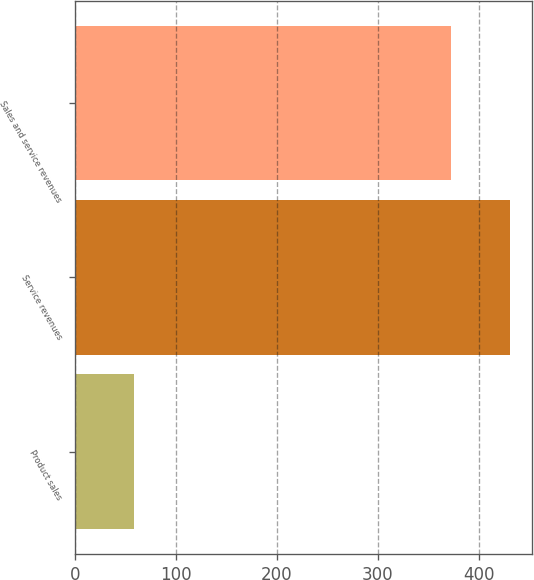<chart> <loc_0><loc_0><loc_500><loc_500><bar_chart><fcel>Product sales<fcel>Service revenues<fcel>Sales and service revenues<nl><fcel>58<fcel>431<fcel>373<nl></chart> 